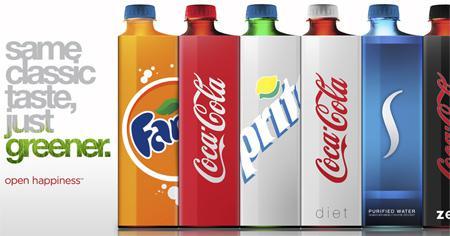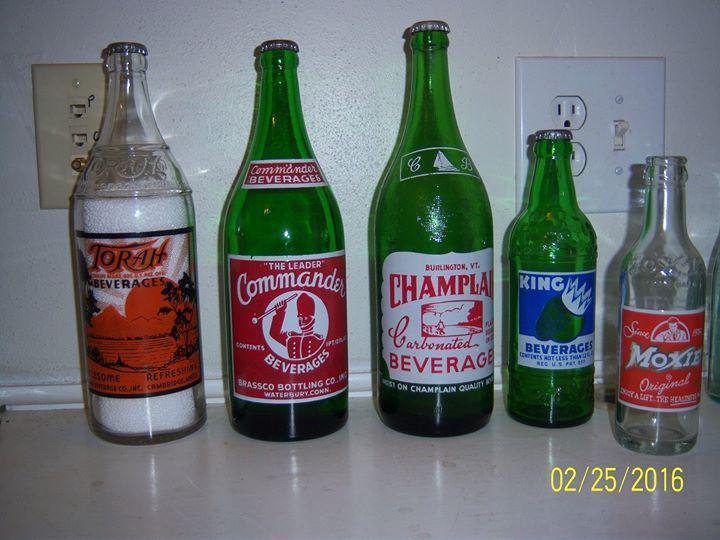The first image is the image on the left, the second image is the image on the right. Analyze the images presented: Is the assertion "There are at least 3 green soda bottles within the rows of bottles." valid? Answer yes or no. Yes. 